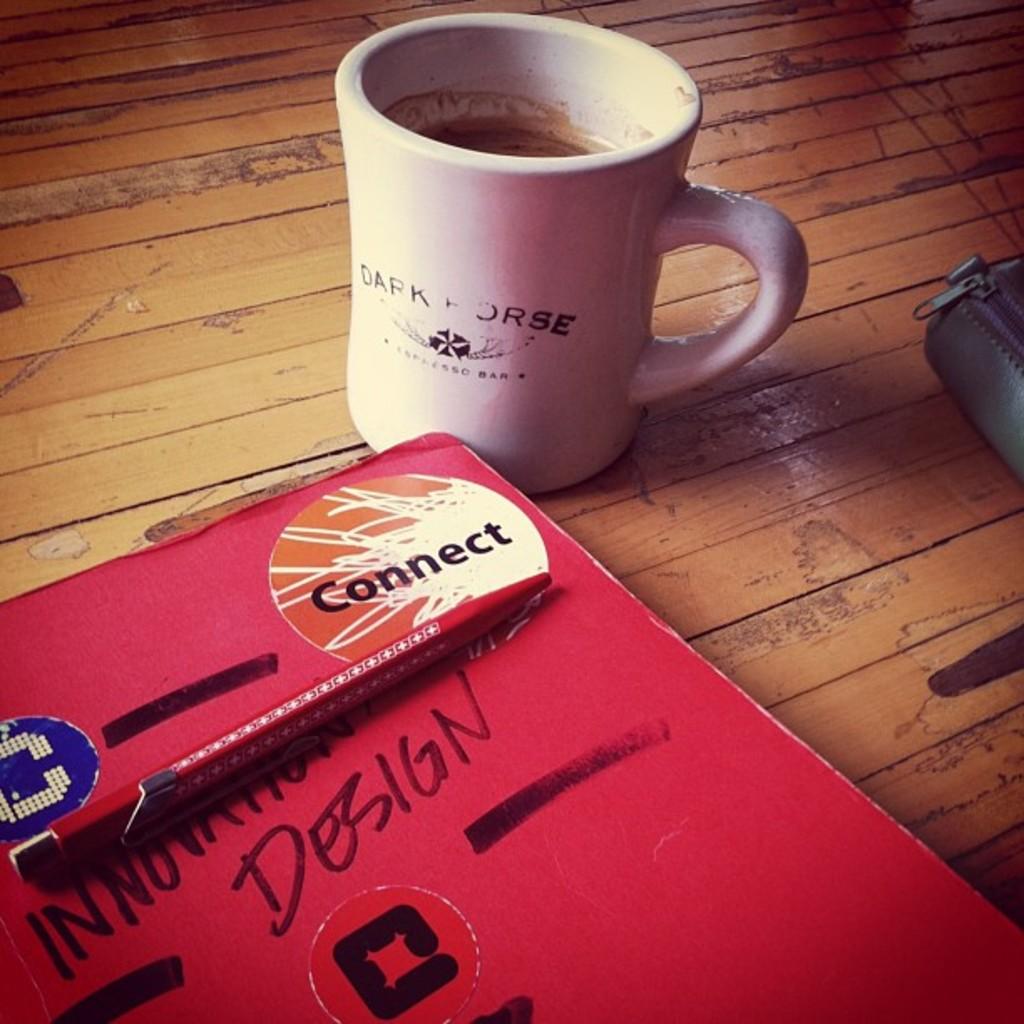What does it say above the pen?
Your answer should be compact. Connect. What does it say on the mug?
Your answer should be very brief. Dark horse. 